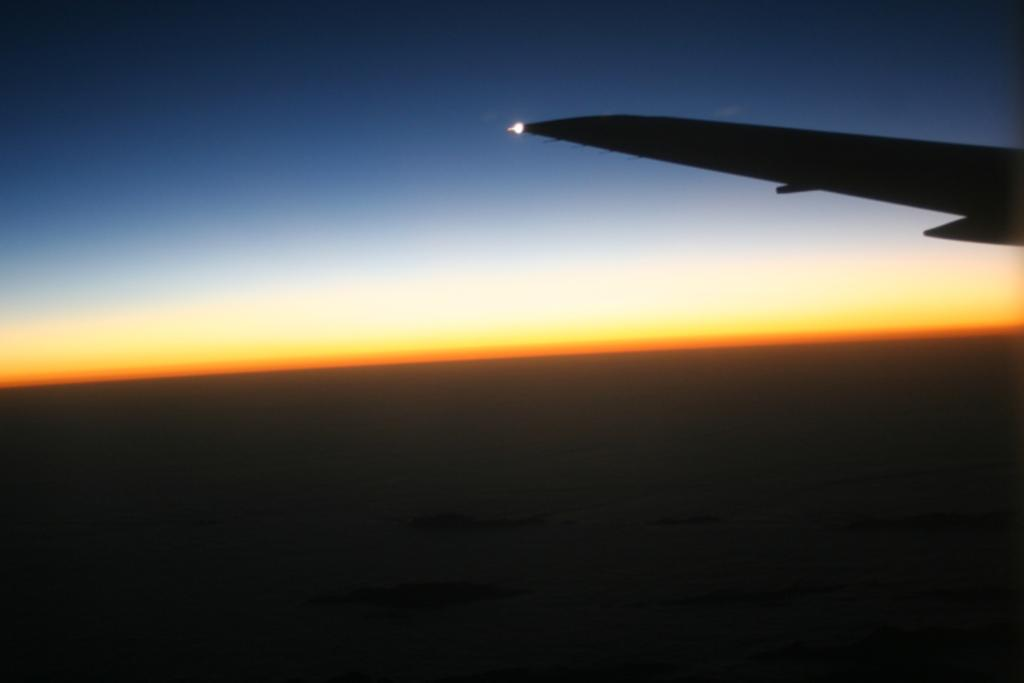What can be seen on the right side of the image? There is an aeroplane wing on the right side of the image. What type of structure can be seen in the background of the image? There is no structure visible in the image; it only features an aeroplane wing on the right side. Can you spot a mountain in the image? There is no mountain present in the image; it only features an aeroplane wing on the right side. 